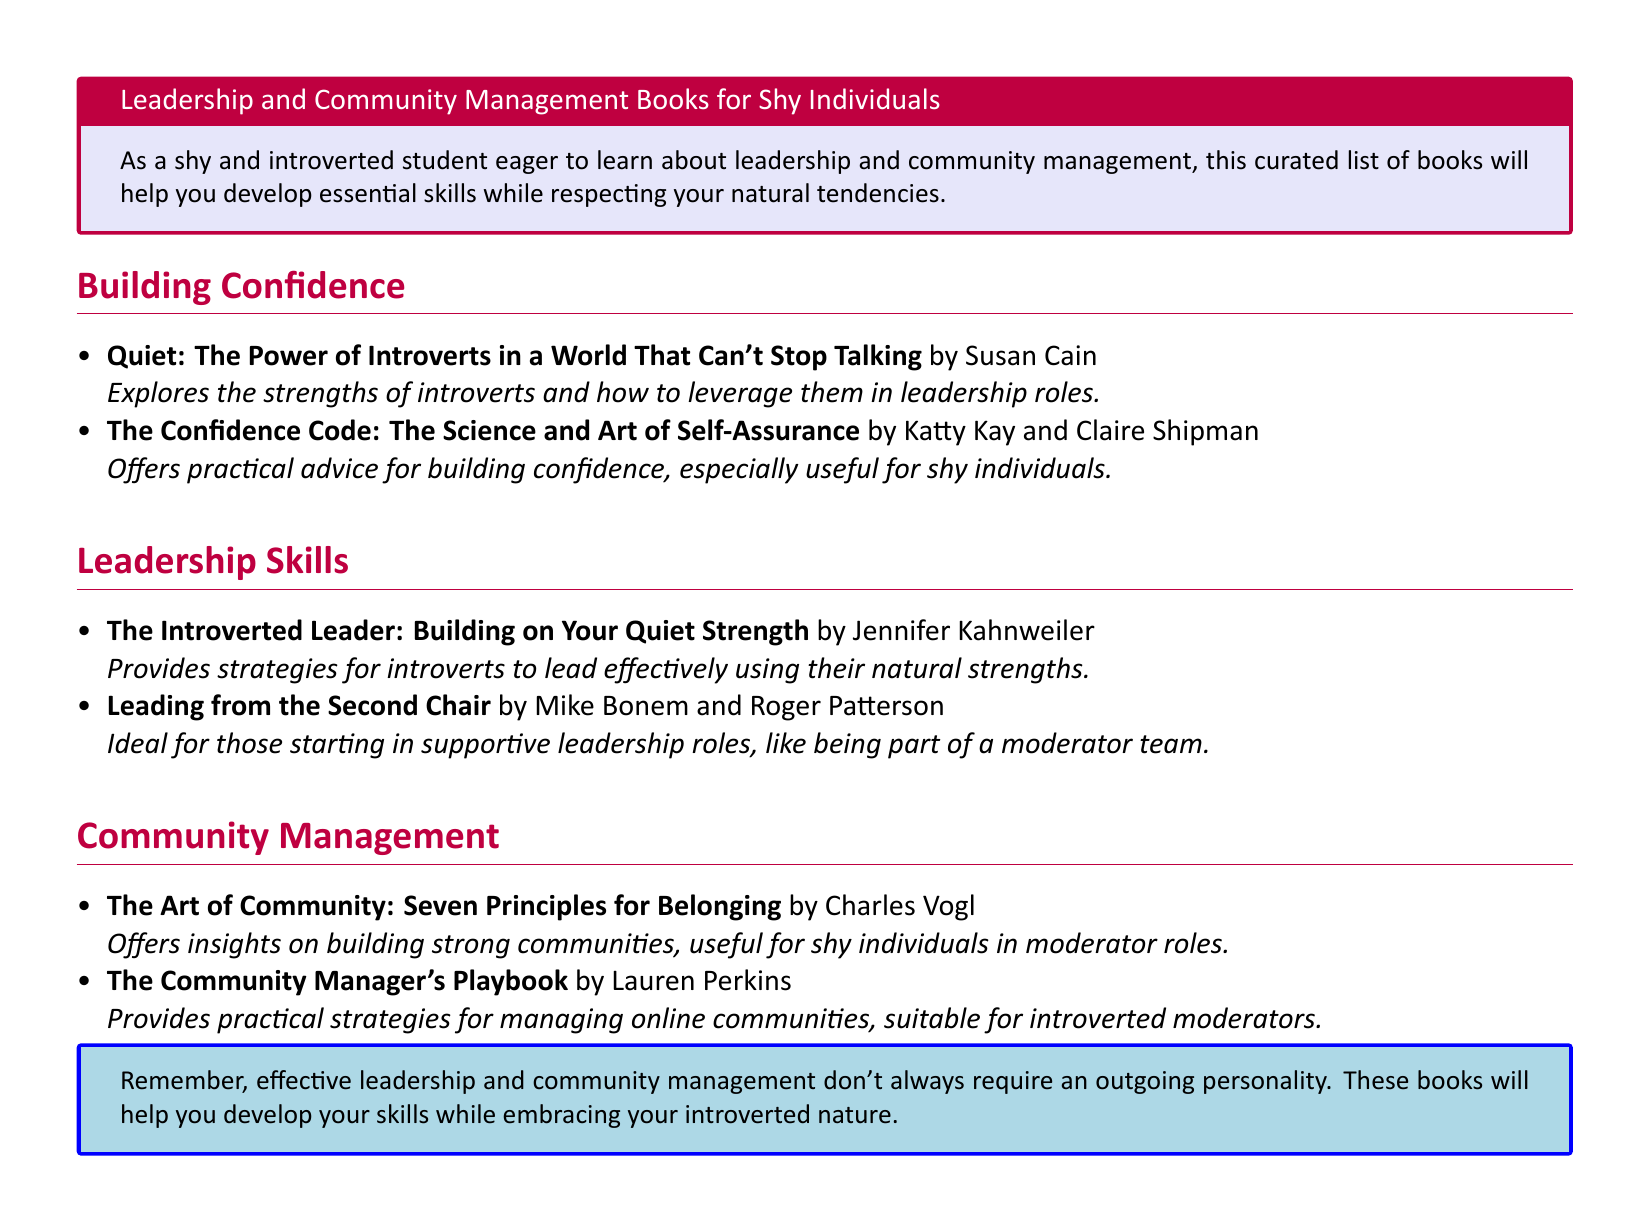What is the title of the first recommended book? The title of the first recommended book is found in the "Building Confidence" section.
Answer: Quiet: The Power of Introverts in a World That Can't Stop Talking Who is the author of "The Confidence Code"? The author's names are listed alongside the book title in the "Building Confidence" section.
Answer: Katty Kay and Claire Shipman How many books are listed under Leadership Skills? The number of books can be counted in the "Leadership Skills" section.
Answer: 2 What is the main focus of "The Art of Community"? The main focus is described in the book's brief summary in the "Community Management" section.
Answer: Building strong communities Which book is described as ideal for supportive leadership roles? The description of the book points to its suitability in the "Leadership Skills" section.
Answer: Leading from the Second Chair What color is the box containing the conclusion? The color is specified in the document as part of the box style.
Answer: Shy blue Name one author who wrote about introverted leadership. The author is mentioned in the "Leadership Skills" section next to their book title.
Answer: Jennifer Kahnweiler What is the purpose of the catalog as stated at the beginning? The purpose is articulated in the introductory tcolorbox at the top of the document.
Answer: Help you develop essential skills 